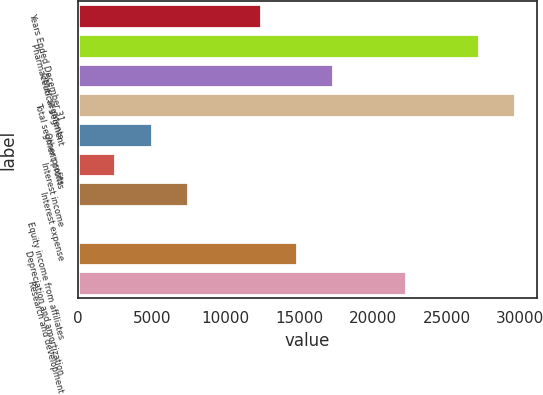Convert chart. <chart><loc_0><loc_0><loc_500><loc_500><bar_chart><fcel>Years Ended December 31<fcel>Pharmaceutical segment<fcel>Other segments<fcel>Total segment profits<fcel>Other profits<fcel>Interest income<fcel>Interest expense<fcel>Equity income from affiliates<fcel>Depreciation and amortization<fcel>Research and development<nl><fcel>12384.5<fcel>27175.1<fcel>17314.7<fcel>29640.2<fcel>4989.2<fcel>2524.1<fcel>7454.3<fcel>59<fcel>14849.6<fcel>22244.9<nl></chart> 